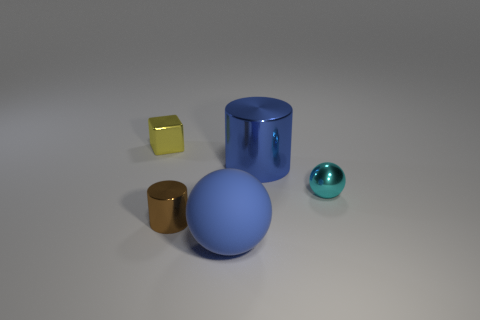There is a tiny shiny thing on the right side of the blue matte sphere; what color is it? The tiny object to the right of the blue matte sphere appears iridescent, displaying various hues, but cyan seems to be the dominant color visible from this perspective. 